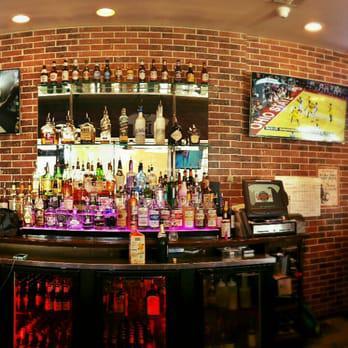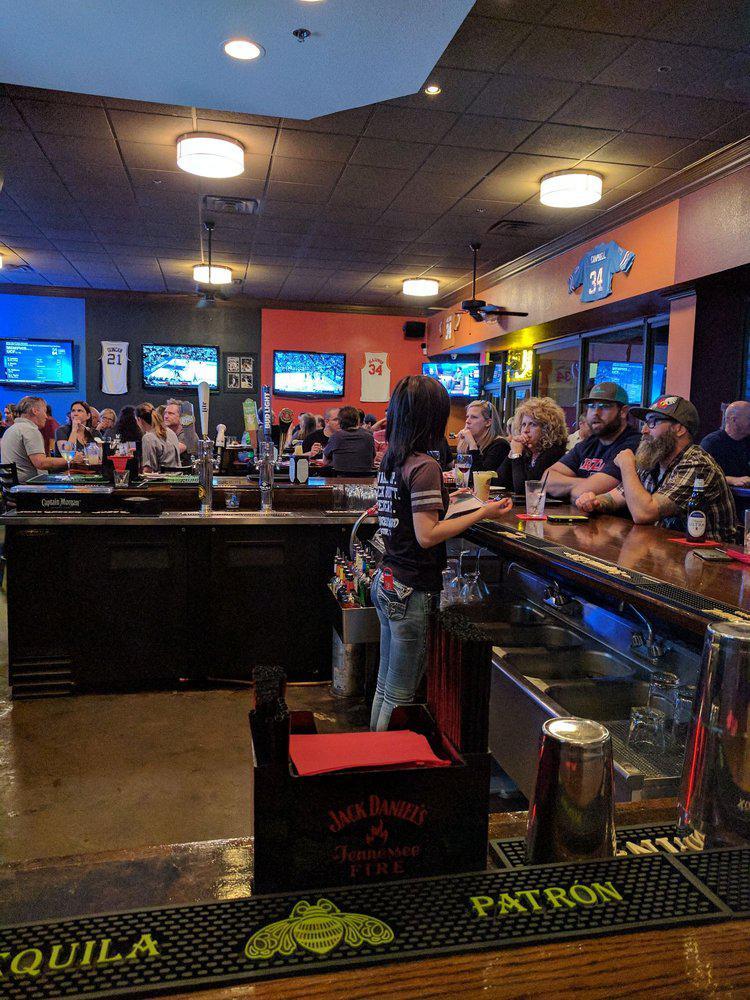The first image is the image on the left, the second image is the image on the right. Given the left and right images, does the statement "One scoreboard is lit up with neon red and yellow colors." hold true? Answer yes or no. No. The first image is the image on the left, the second image is the image on the right. For the images shown, is this caption "One image shows two camera-facing smiling women posed side-by-side behind a table-like surface." true? Answer yes or no. No. 